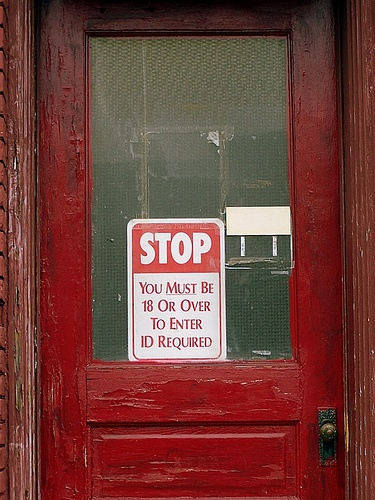Describe the objects in this image and their specific colors. I can see a stop sign in brown, lightgray, salmon, and lightpink tones in this image. 